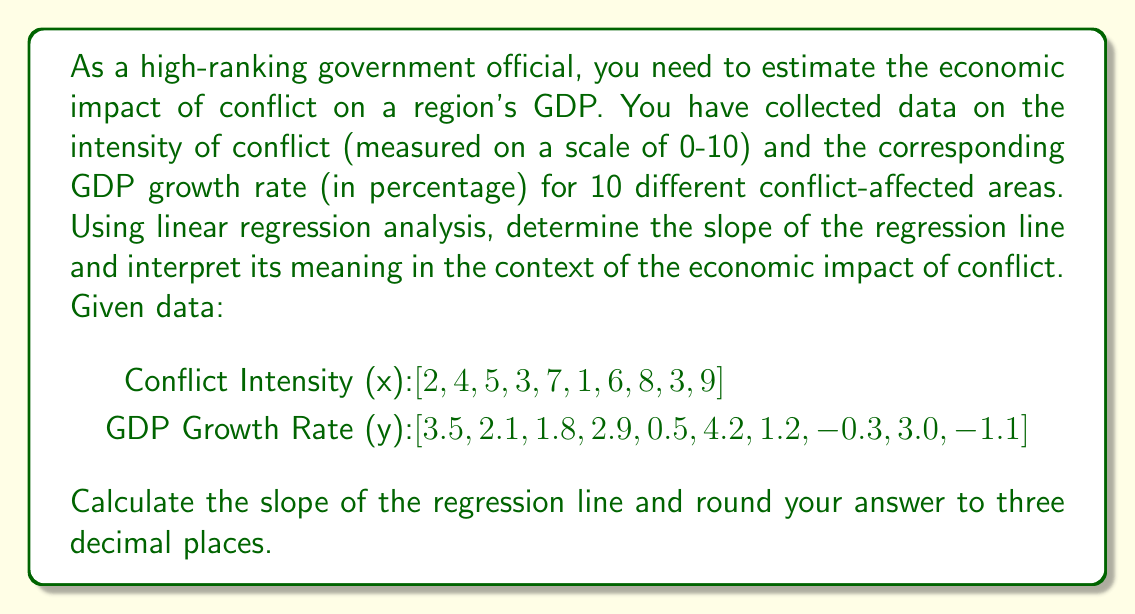Can you solve this math problem? To calculate the slope of the regression line, we'll use the formula:

$$ \beta_1 = \frac{n\sum xy - \sum x \sum y}{n\sum x^2 - (\sum x)^2} $$

Where:
$\beta_1$ is the slope of the regression line
$n$ is the number of data points
$x$ is the conflict intensity
$y$ is the GDP growth rate

Step 1: Calculate the required sums:
$n = 10$
$\sum x = 48$
$\sum y = 17.8$
$\sum xy = 66.3$
$\sum x^2 = 300$

Step 2: Apply the formula:

$$ \beta_1 = \frac{10(66.3) - (48)(17.8)}{10(300) - (48)^2} $$

$$ \beta_1 = \frac{663 - 854.4}{3000 - 2304} $$

$$ \beta_1 = \frac{-191.4}{696} $$

$$ \beta_1 \approx -0.275 $$

Step 3: Interpret the result:
The slope of -0.275 indicates that for each one-unit increase in conflict intensity, the GDP growth rate is expected to decrease by 0.275 percentage points, on average.

This negative relationship suggests that higher conflict intensity is associated with lower economic growth, quantifying the adverse economic impact of conflict in the region.
Answer: -0.275 